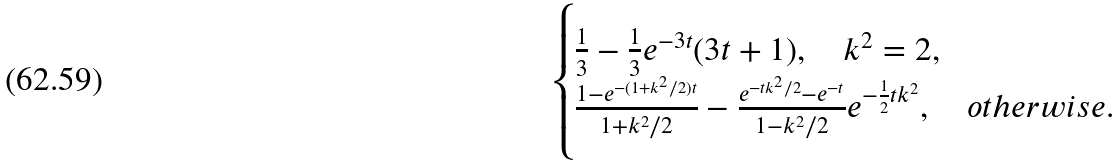<formula> <loc_0><loc_0><loc_500><loc_500>\begin{cases} \frac { 1 } { 3 } - \frac { 1 } { 3 } e ^ { - 3 t } ( 3 t + 1 ) , \quad k ^ { 2 } = 2 , \\ \frac { 1 - e ^ { - ( 1 + k ^ { 2 } / 2 ) t } } { 1 + k ^ { 2 } / 2 } - \frac { e ^ { - t k ^ { 2 } / 2 } - e ^ { - t } } { 1 - k ^ { 2 } / 2 } e ^ { - \frac { 1 } { 2 } t k ^ { 2 } } , \quad o t h e r w i s e . \end{cases}</formula> 